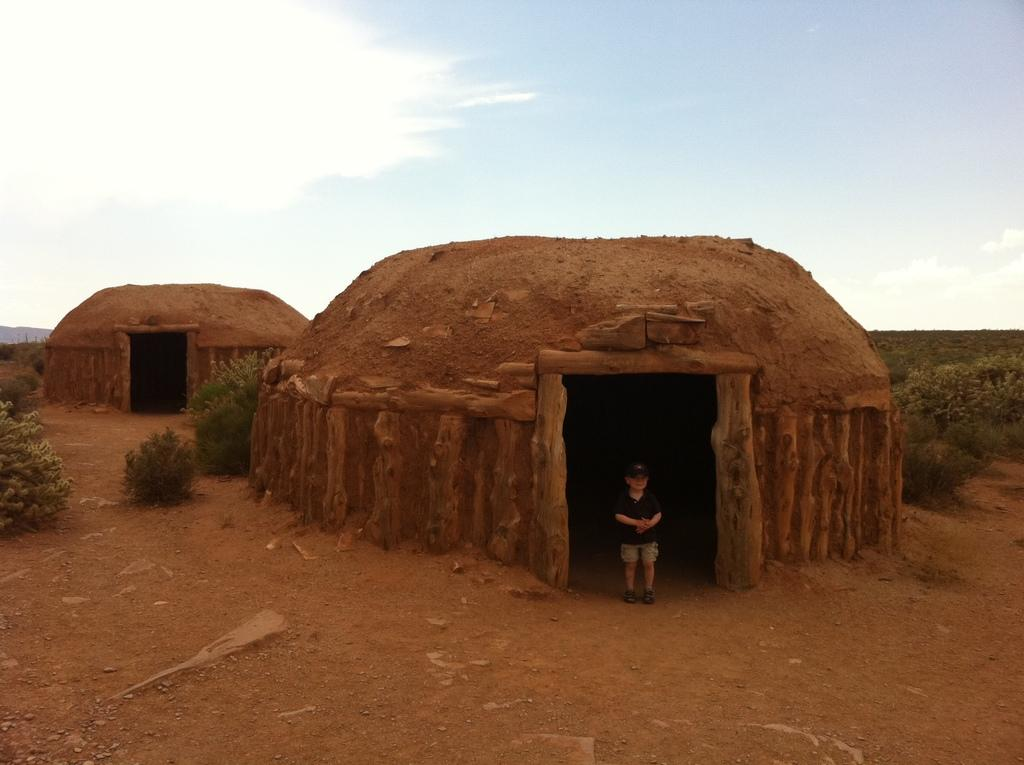Who is the main subject in the image? There is a small boy in the image. What is the boy doing in the image? The boy is standing in front of the ground. What structure can be seen in the image? There is a mud igloo in the image. What type of vegetation is present in the image? There are plants in the image. What is visible in the background of the image? The sky is visible in the image, and clouds are present in the sky. What type of linen is draped over the carriage in the image? There is no carriage or linen present in the image. What question is the boy asking in the image? The image does not show the boy asking a question. 